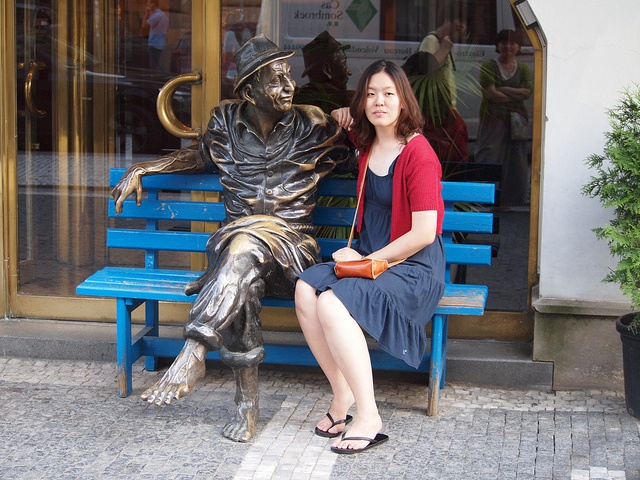Describe the objects in this image and their specific colors. I can see people in olive, lightgray, gray, lightpink, and black tones, bench in olive, gray, blue, and black tones, potted plant in olive, black, lightgray, darkgray, and gray tones, people in olive, black, maroon, and gray tones, and people in olive, black, maroon, and darkgreen tones in this image. 